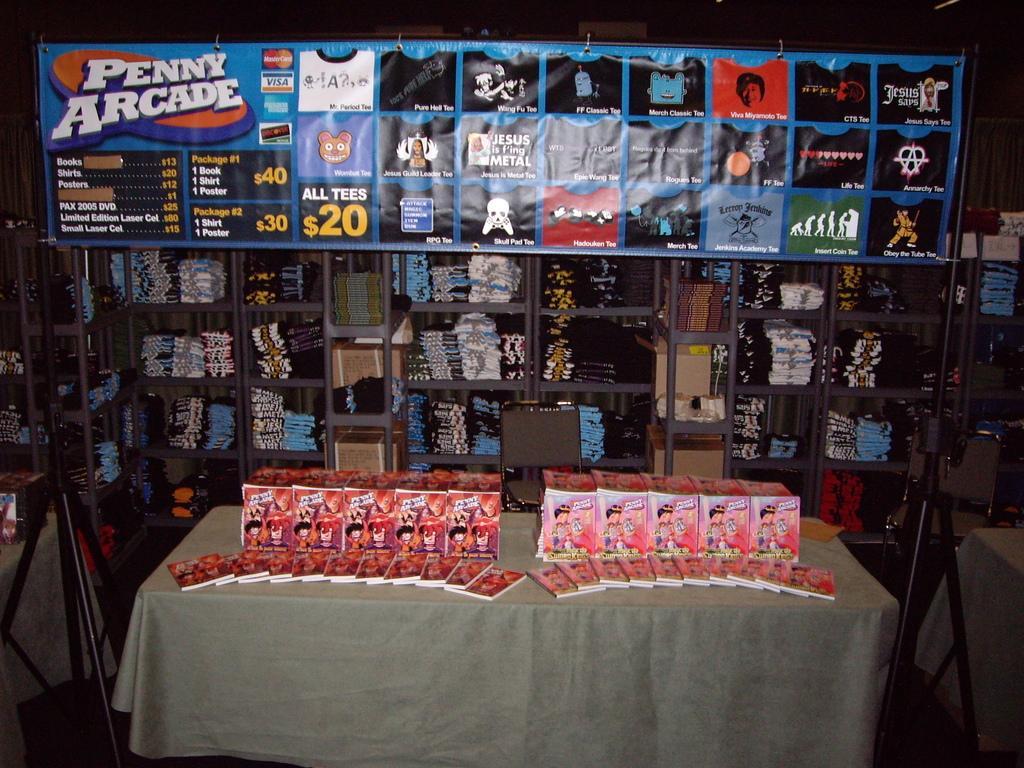Could you give a brief overview of what you see in this image? In this image there is a table, on that table there is a cloth, on that there are few objects, in the background there are racks in that racks there are few objects, at the top there is a banner, on that banner there is some text and pictures. 